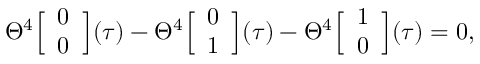Convert formula to latex. <formula><loc_0><loc_0><loc_500><loc_500>\Theta ^ { 4 } \left [ \begin{array} { c } { 0 } \\ { 0 } \end{array} \right ] ( \tau ) - \Theta ^ { 4 } \left [ \begin{array} { c } { 0 } \\ { 1 } \end{array} \right ] ( \tau ) - \Theta ^ { 4 } \left [ \begin{array} { c } { 1 } \\ { 0 } \end{array} \right ] ( \tau ) = 0 ,</formula> 